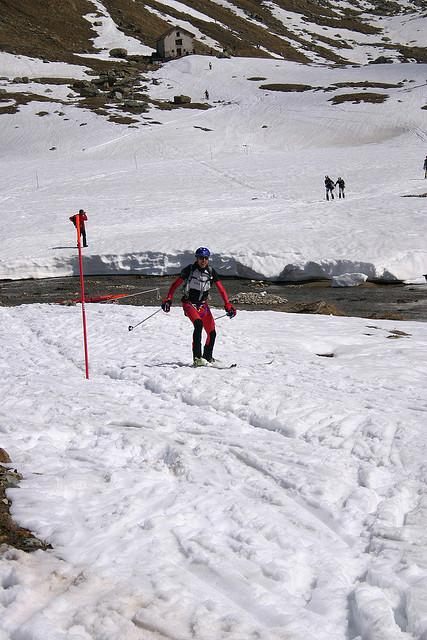What time of day is this?

Choices:
A) dawn
B) afternoon
C) midday
D) dusk midday 